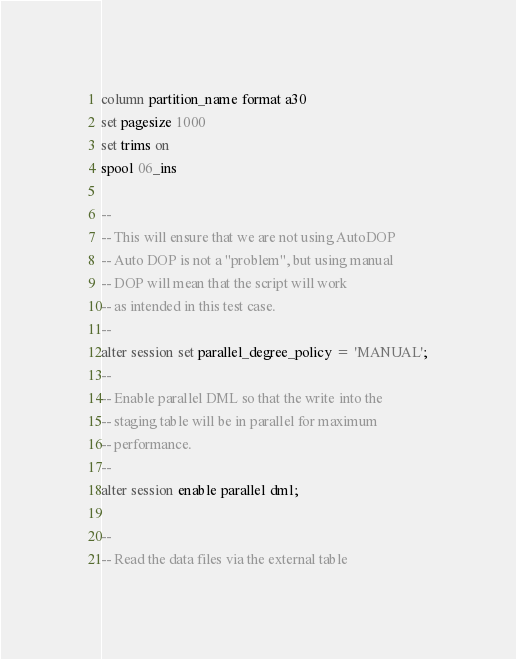<code> <loc_0><loc_0><loc_500><loc_500><_SQL_>column partition_name format a30
set pagesize 1000
set trims on
spool 06_ins

--
-- This will ensure that we are not using AutoDOP
-- Auto DOP is not a "problem", but using manual
-- DOP will mean that the script will work
-- as intended in this test case.
--
alter session set parallel_degree_policy = 'MANUAL';
--
-- Enable parallel DML so that the write into the
-- staging table will be in parallel for maximum
-- performance.
--
alter session enable parallel dml;

--
-- Read the data files via the external table</code> 